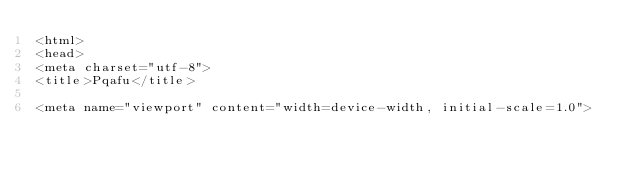Convert code to text. <code><loc_0><loc_0><loc_500><loc_500><_PHP_><html>
<head>
<meta charset="utf-8">
<title>Pqafu</title>

<meta name="viewport" content="width=device-width, initial-scale=1.0">
</code> 